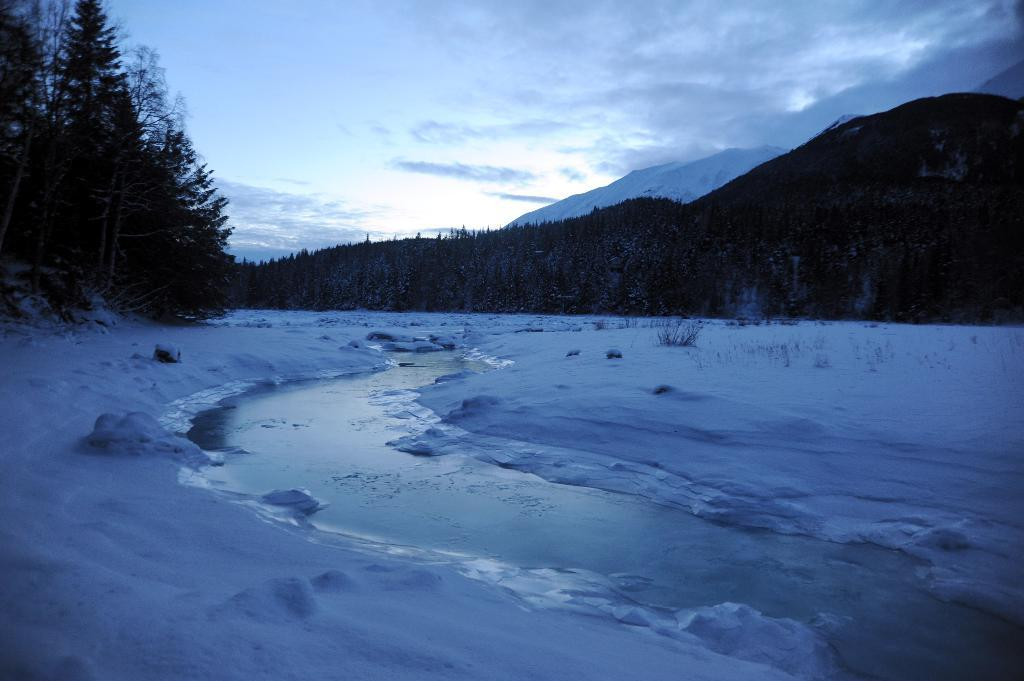What type of natural features can be seen in the image? There are trees and hills visible in the image. What is present at the bottom of the image? There is water and snow visible at the bottom of the image. What is visible at the top of the image? The sky is visible at the top of the image. Can you find the receipt for the fan purchase in the image? There is no receipt or fan present in the image; it features natural elements such as trees, hills, water, snow, and the sky. 